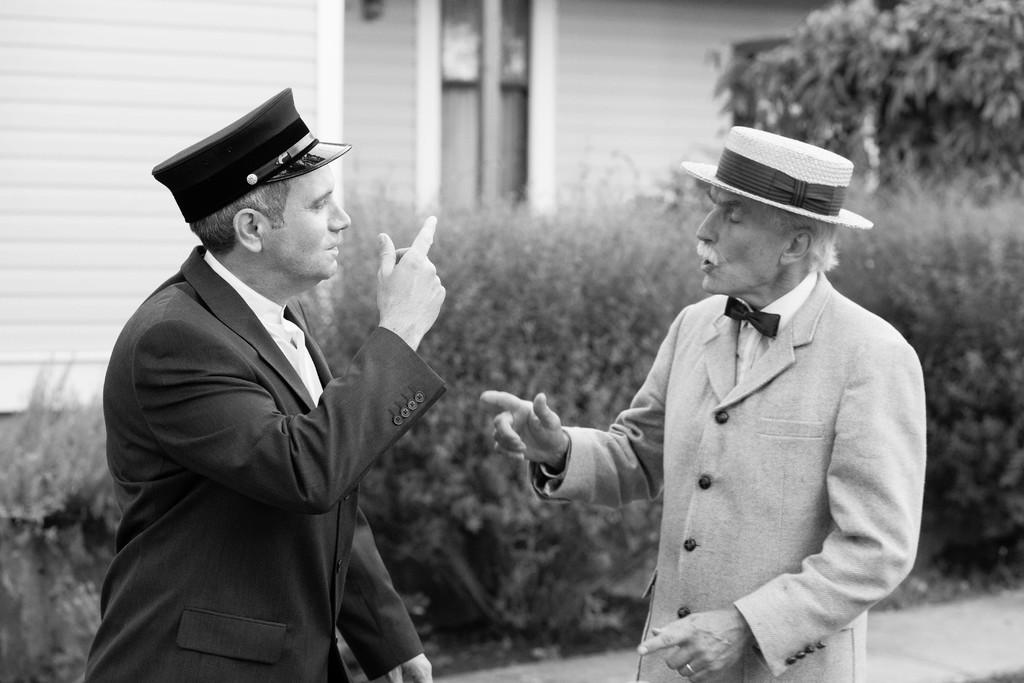How many people are present in the image? There are two people in the image. Where are the people located in the image? The people are standing in the center of the image. What can be seen in the background of the image? There is a building and plants in the background of the image. What type of scent can be detected coming from the prison in the image? There is no prison present in the image, so it is not possible to determine what scent might be detected. 